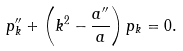<formula> <loc_0><loc_0><loc_500><loc_500>p ^ { \prime \prime } _ { k } + \left ( k ^ { 2 } - \frac { a ^ { \prime \prime } } { a } \right ) p _ { k } = 0 .</formula> 